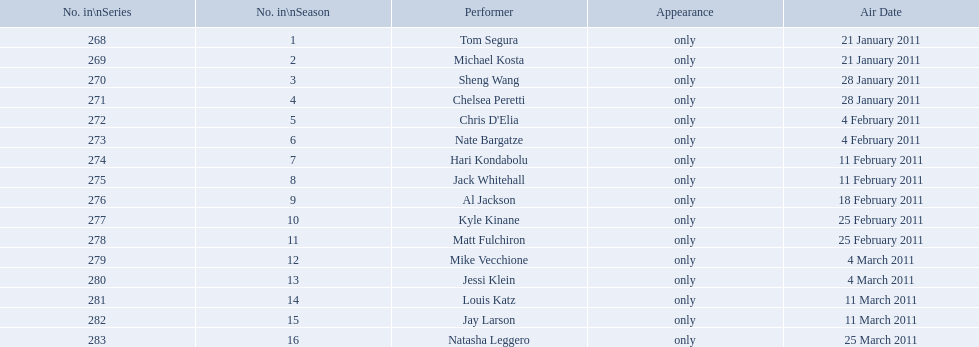Who appeared first tom segura or jay larson? Tom Segura. 